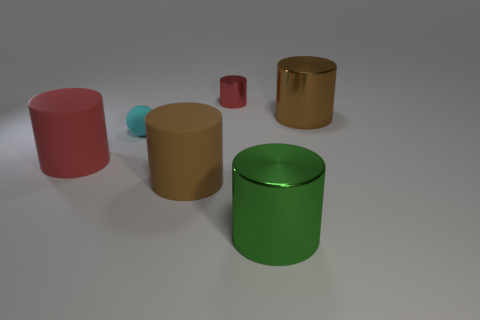Subtract all big red rubber cylinders. How many cylinders are left? 4 Subtract all green cylinders. How many cylinders are left? 4 Subtract all yellow cylinders. Subtract all purple blocks. How many cylinders are left? 5 Add 2 gray matte cubes. How many objects exist? 8 Subtract all balls. How many objects are left? 5 Add 6 big matte cylinders. How many big matte cylinders are left? 8 Add 4 blue rubber objects. How many blue rubber objects exist? 4 Subtract 0 blue spheres. How many objects are left? 6 Subtract all brown cubes. Subtract all red metal cylinders. How many objects are left? 5 